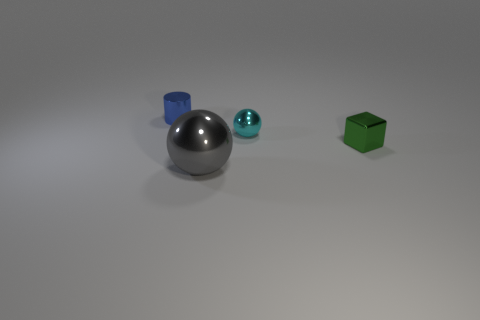What number of other objects are there of the same shape as the cyan metal object? There is one other object of the same shape as the cyan metal object, which is the silver sphere. This can be observed by comparing the shapes and noticing that both the cyan and silver objects share a spherical geometry, distinguishing them from the cube-shaped green object. 